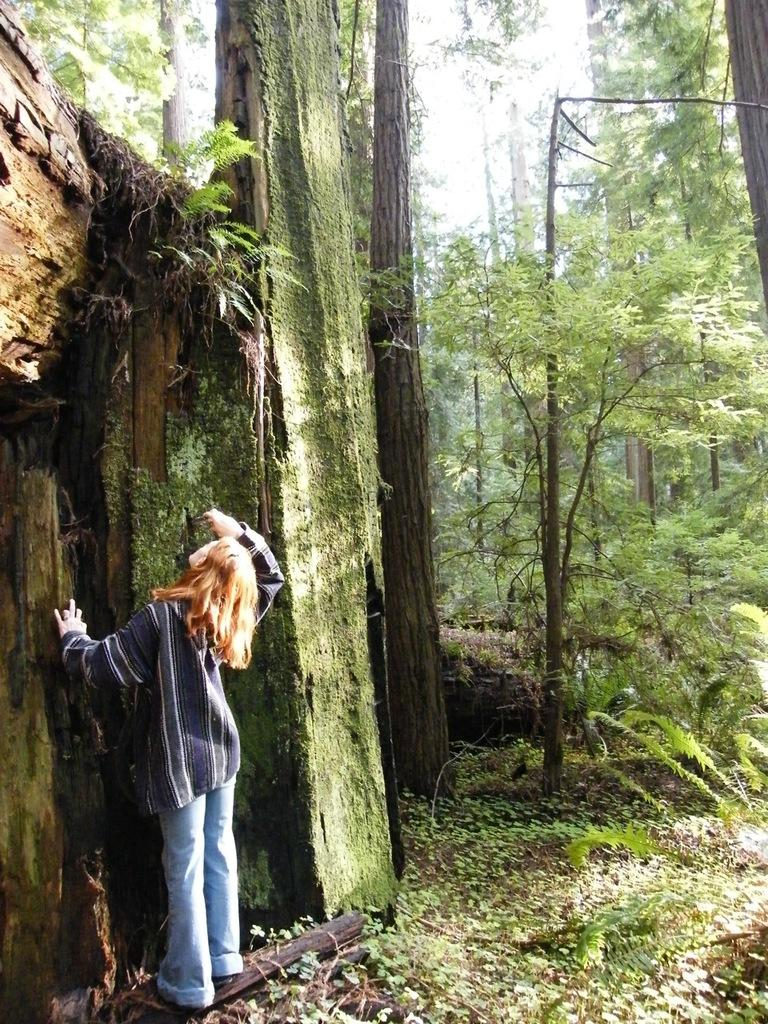What is the main subject in the image? There is a person standing in the image. What type of natural elements can be seen in the image? There are plants and trees visible in the image. What is visible in the background of the image? The sky is visible in the image. Where is the vase located in the image? There is no vase present in the image. What type of sign can be seen in the image? There is no sign present in the image. 